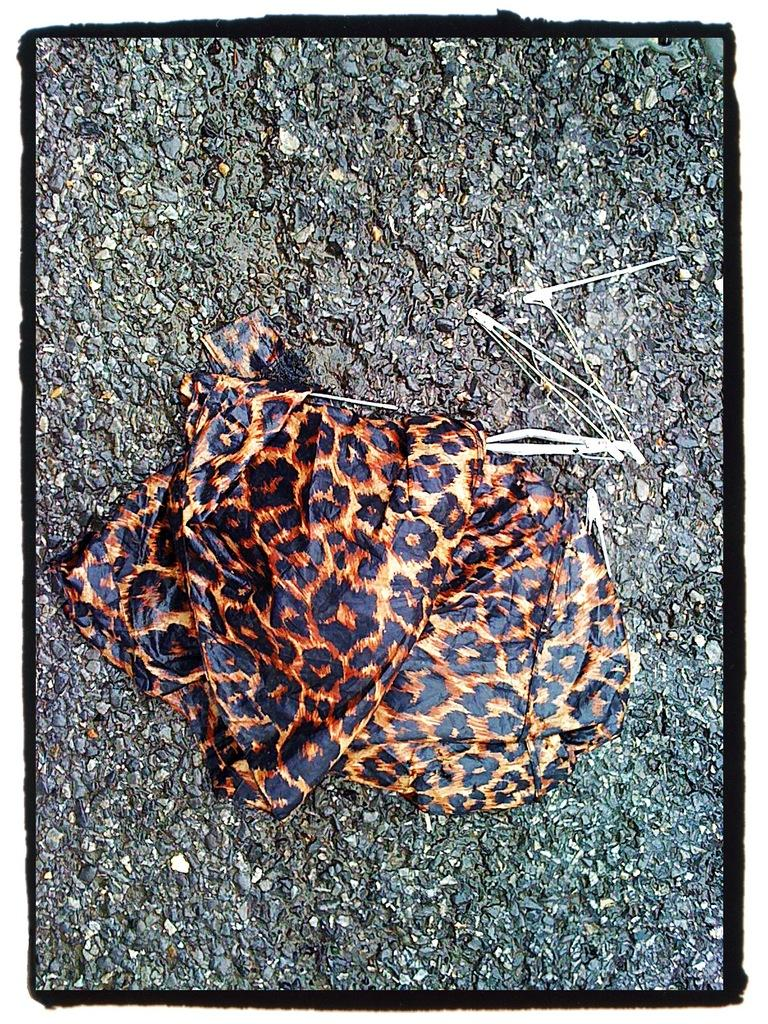What type of surface is visible in the image? There is a surface in the image. What is covering the surface? The surface has a leopard skin design cloth on it. Is there a heart-shaped object visible in the image? There is no heart-shaped object present in the image; it only features a surface with a leopard skin design cloth on it. 